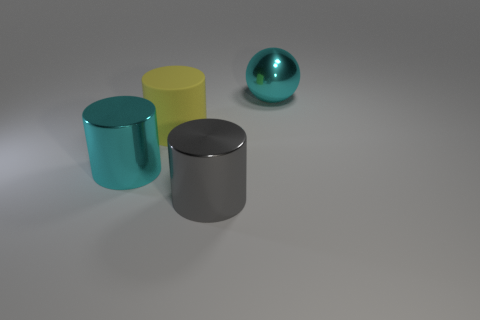There is a thing that is in front of the big cyan object in front of the big ball; what is it made of?
Your answer should be compact. Metal. Is there a large cyan sphere made of the same material as the yellow cylinder?
Your answer should be very brief. No. There is a cylinder that is in front of the cyan metallic cylinder; are there any gray cylinders on the right side of it?
Offer a very short reply. No. What material is the big cyan thing left of the large cyan ball?
Offer a terse response. Metal. Do the large gray object and the big rubber object have the same shape?
Provide a short and direct response. Yes. There is a large metal thing on the left side of the cylinder that is in front of the large cyan metallic cylinder that is in front of the yellow cylinder; what color is it?
Provide a succinct answer. Cyan. What number of other yellow rubber things are the same shape as the yellow object?
Give a very brief answer. 0. There is a shiny object that is in front of the cyan metal thing in front of the big ball; what size is it?
Your answer should be very brief. Large. Do the ball and the cyan metallic cylinder have the same size?
Offer a very short reply. Yes. There is a large cyan thing that is left of the thing behind the yellow rubber object; is there a gray cylinder that is to the left of it?
Ensure brevity in your answer.  No. 